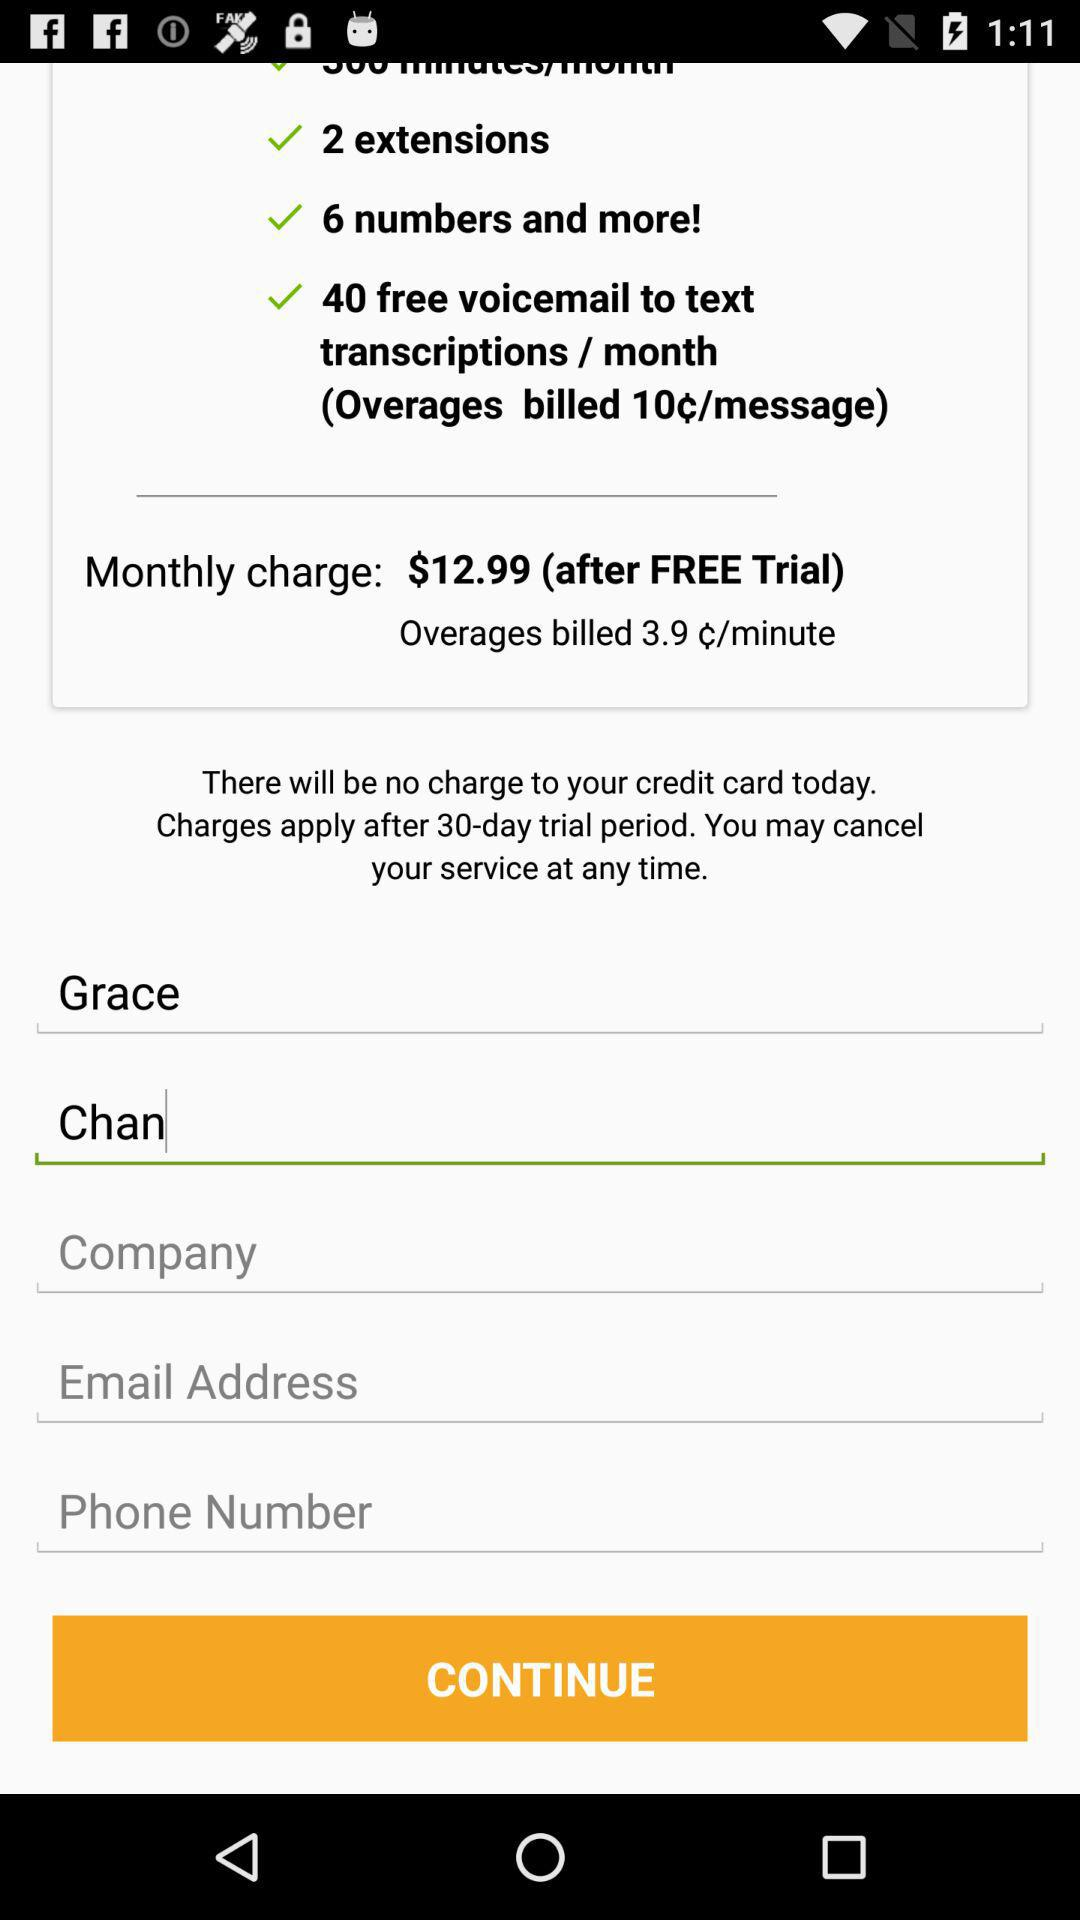What is the name of the user? The name of the user is Grace Chan. 